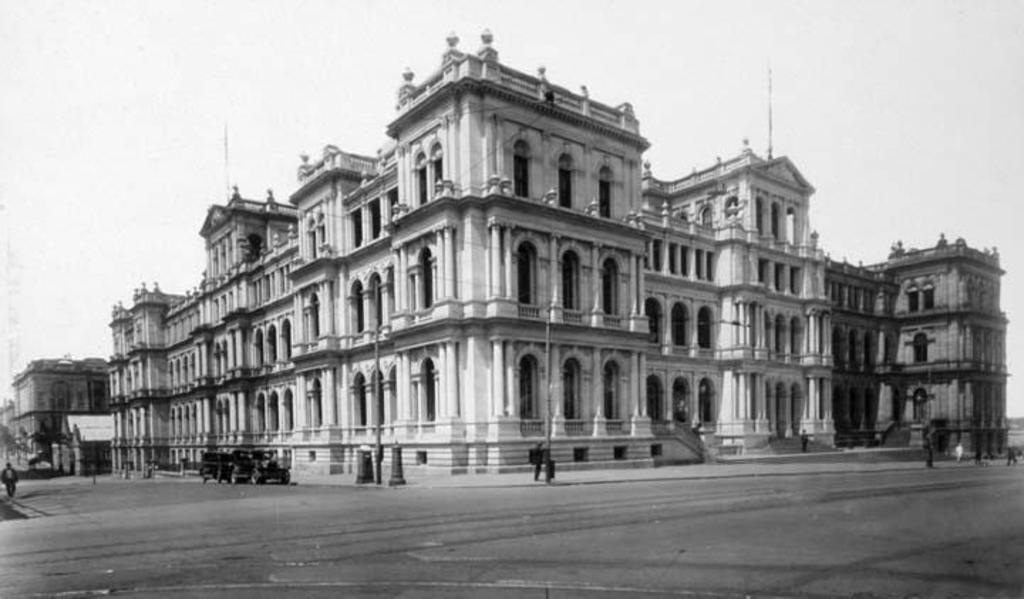What is the color scheme of the image? The image is black and white. What objects can be seen in the image? There are poles and vehicles in the image. Where is the person located in the image? The person is present at the left side of the image. What can be seen in the background of the image? There are buildings in the background of the image. How many ants are crawling on the person's shoulder in the image? There are no ants present in the image. What reward does the boy receive for completing the task in the image? There is no boy present in the image, and no task or reward is depicted. 